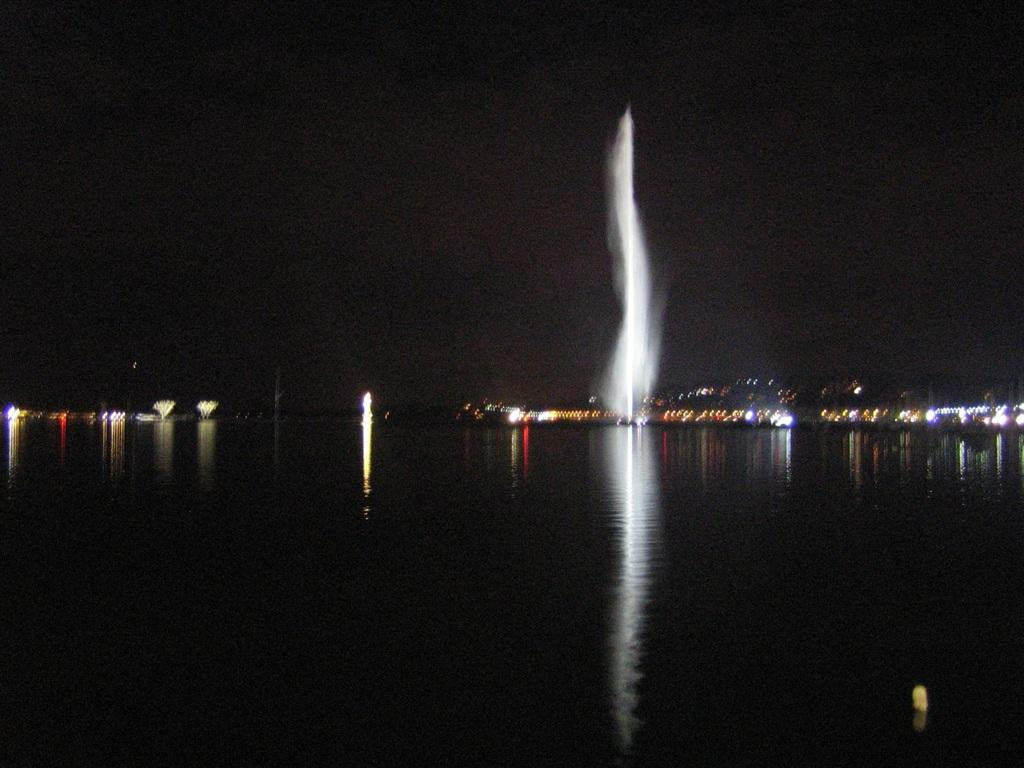What is present in the image that is related to water? There is a fountain in the image, which is related to water. What else can be seen in the image besides the fountain? There are lights visible in the background of the image. What is the color of the sky in the image? The sky is black in color in the image. What type of jelly can be seen floating in the water in the image? There is no jelly present in the image; it features a fountain and lights in the background. In which direction is the fountain facing in the image? The image does not provide information about the direction the fountain is facing, so it cannot be determined. 